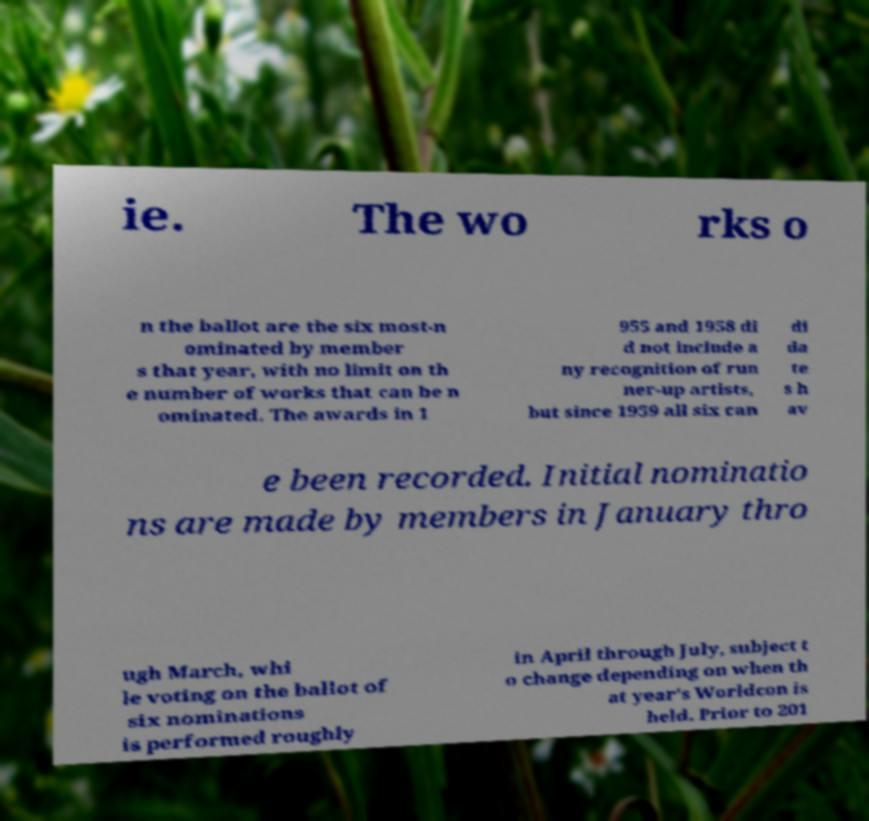I need the written content from this picture converted into text. Can you do that? ie. The wo rks o n the ballot are the six most-n ominated by member s that year, with no limit on th e number of works that can be n ominated. The awards in 1 955 and 1958 di d not include a ny recognition of run ner-up artists, but since 1959 all six can di da te s h av e been recorded. Initial nominatio ns are made by members in January thro ugh March, whi le voting on the ballot of six nominations is performed roughly in April through July, subject t o change depending on when th at year's Worldcon is held. Prior to 201 